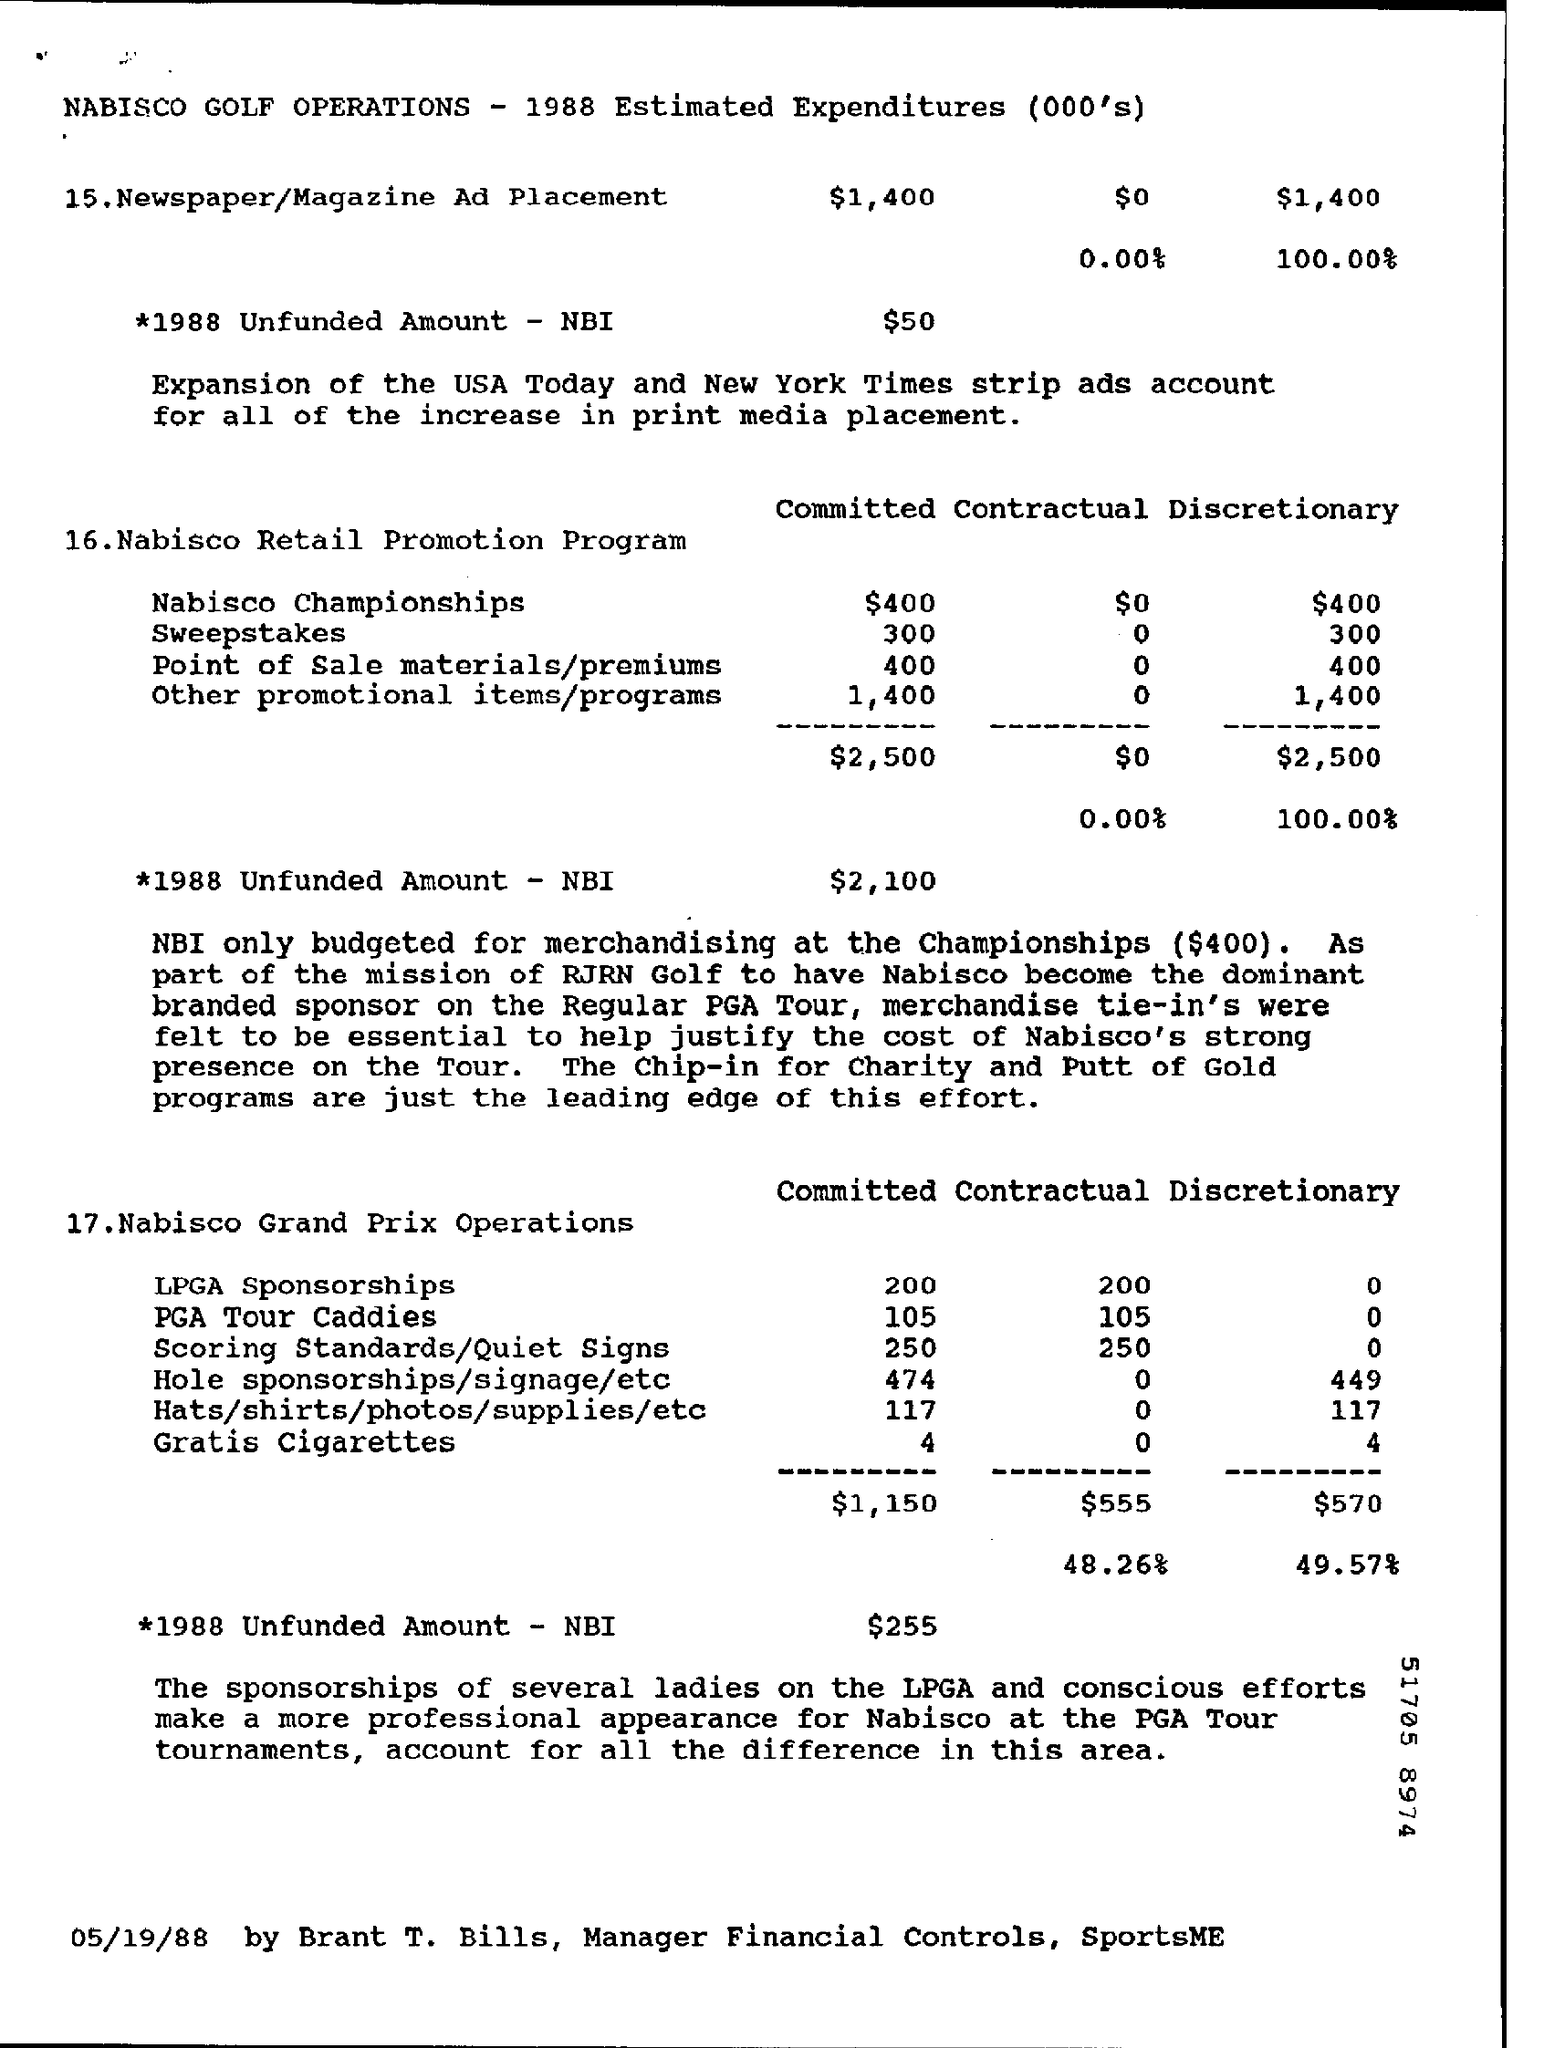List a handful of essential elements in this visual. The committed amount for the Nabisco Championships is $400. What is the quantity of free cigarettes being committed? What is the contractual for PGA Tour caddies? 105 is a common question among caddies and other golf enthusiasts. The committed amount for LPGA sponsorships is currently 200.. The committed amount for the sweepstakes is 300. 